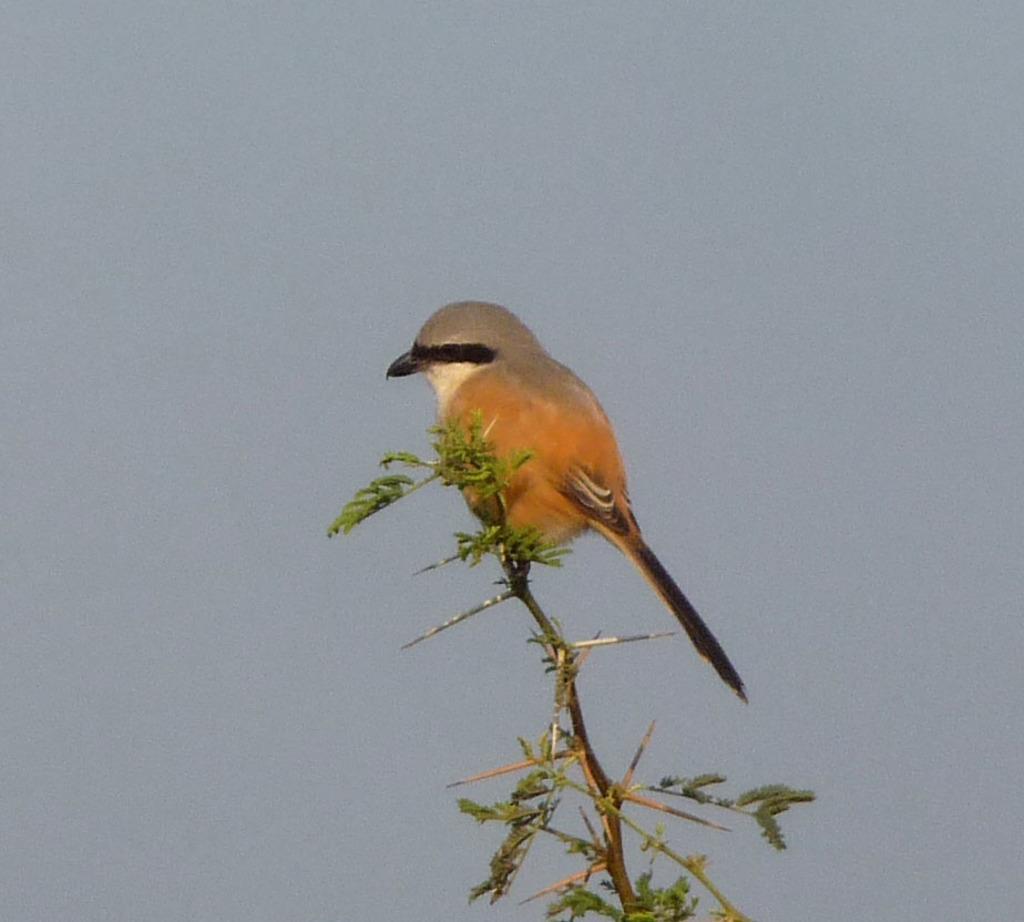How would you summarize this image in a sentence or two? In this image we can see a bird on the branch of a tree and we can see some leaves. 